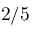Convert formula to latex. <formula><loc_0><loc_0><loc_500><loc_500>2 / 5</formula> 